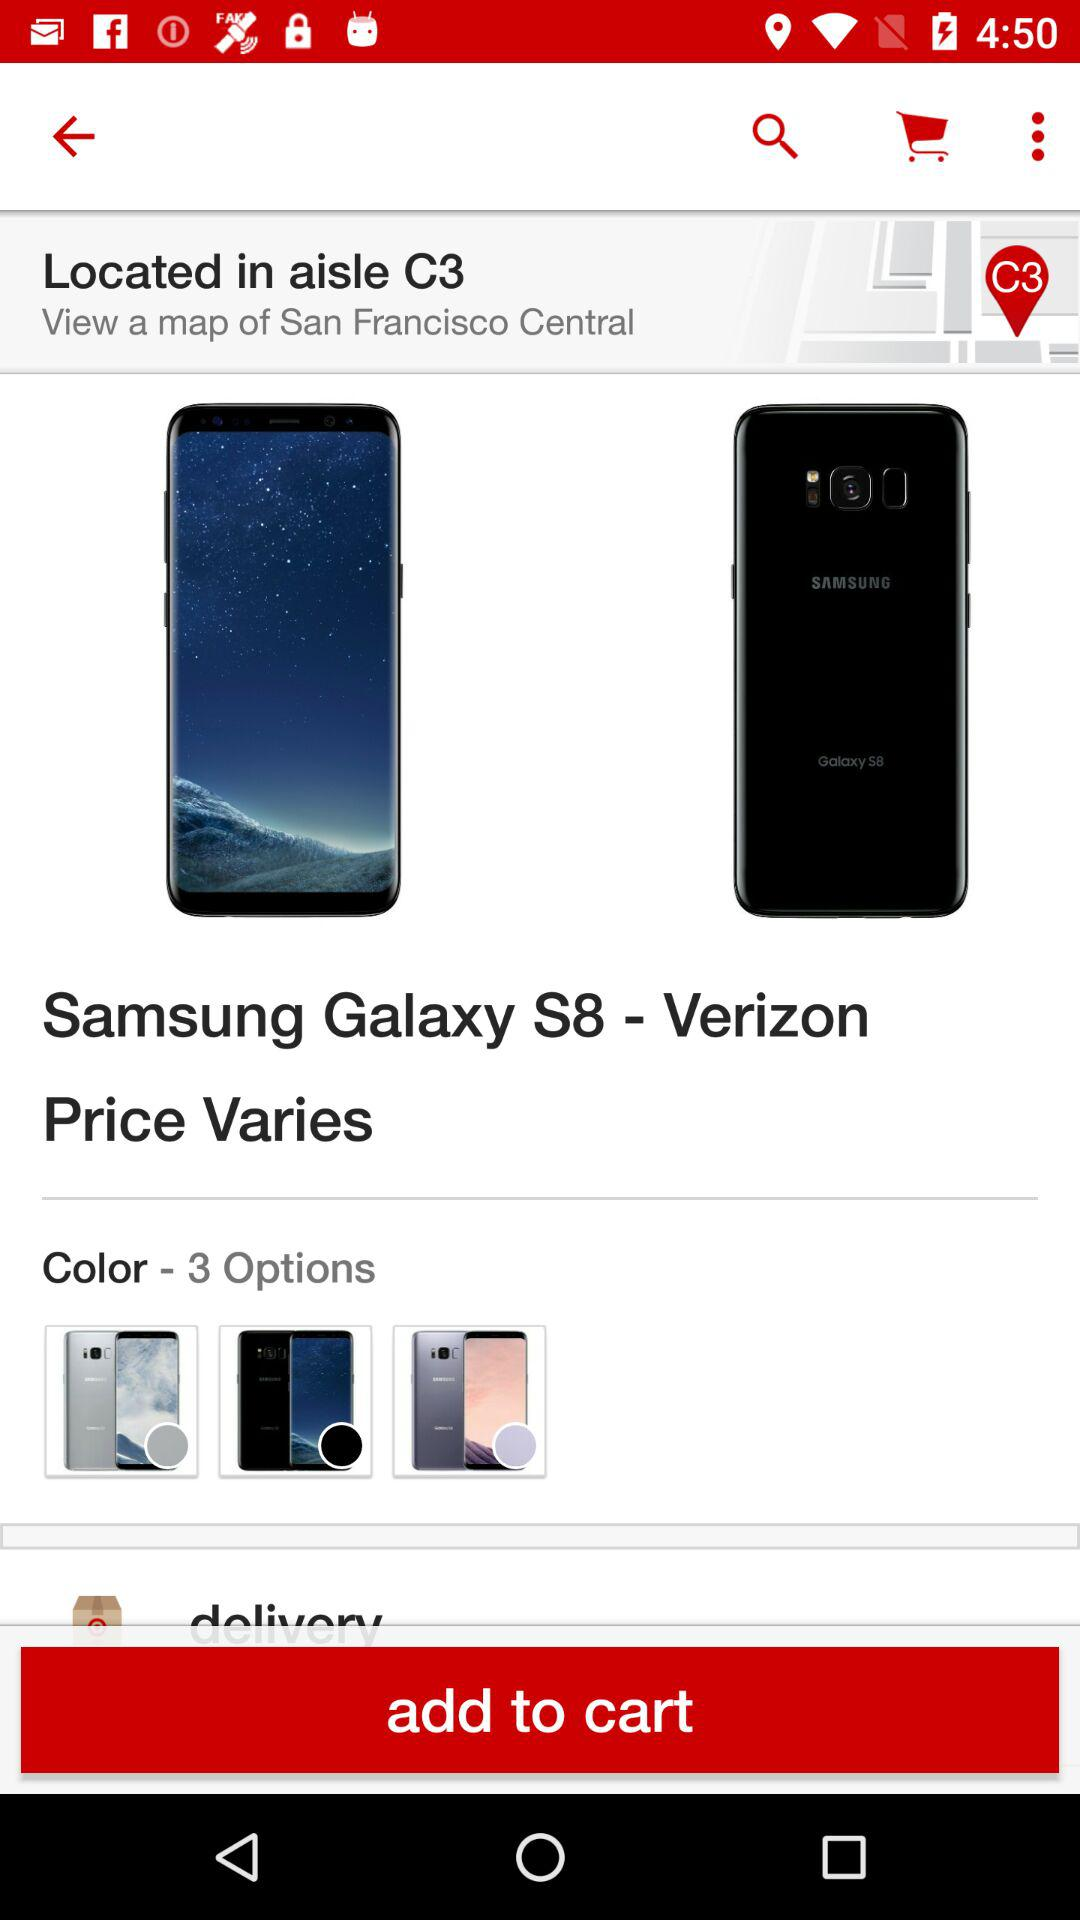How many color options are available for this item?
Answer the question using a single word or phrase. 3 